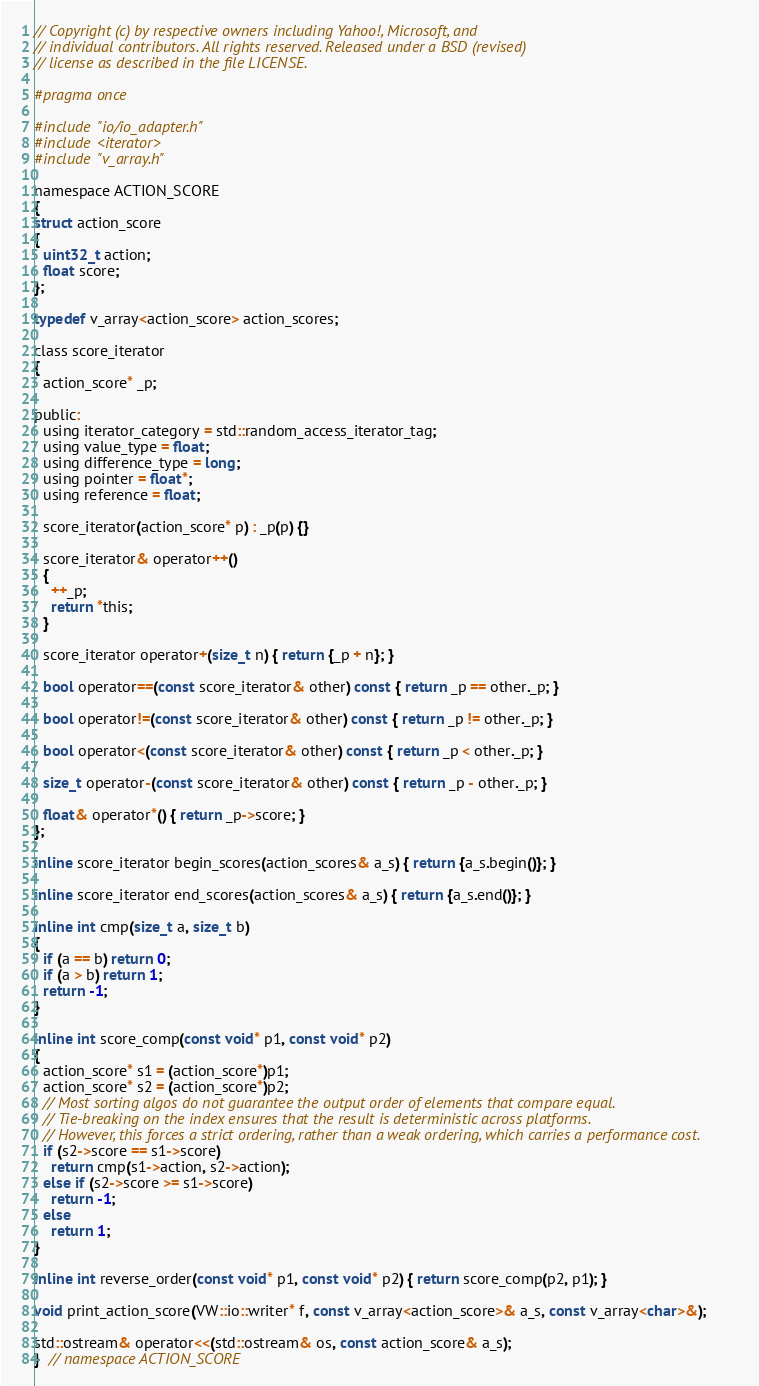<code> <loc_0><loc_0><loc_500><loc_500><_C_>// Copyright (c) by respective owners including Yahoo!, Microsoft, and
// individual contributors. All rights reserved. Released under a BSD (revised)
// license as described in the file LICENSE.

#pragma once

#include "io/io_adapter.h"
#include <iterator>
#include "v_array.h"

namespace ACTION_SCORE
{
struct action_score
{
  uint32_t action;
  float score;
};

typedef v_array<action_score> action_scores;

class score_iterator
{
  action_score* _p;

public:
  using iterator_category = std::random_access_iterator_tag;
  using value_type = float;
  using difference_type = long;
  using pointer = float*;
  using reference = float;

  score_iterator(action_score* p) : _p(p) {}

  score_iterator& operator++()
  {
    ++_p;
    return *this;
  }

  score_iterator operator+(size_t n) { return {_p + n}; }

  bool operator==(const score_iterator& other) const { return _p == other._p; }

  bool operator!=(const score_iterator& other) const { return _p != other._p; }

  bool operator<(const score_iterator& other) const { return _p < other._p; }

  size_t operator-(const score_iterator& other) const { return _p - other._p; }

  float& operator*() { return _p->score; }
};

inline score_iterator begin_scores(action_scores& a_s) { return {a_s.begin()}; }

inline score_iterator end_scores(action_scores& a_s) { return {a_s.end()}; }

inline int cmp(size_t a, size_t b)
{
  if (a == b) return 0;
  if (a > b) return 1;
  return -1;
}

inline int score_comp(const void* p1, const void* p2)
{
  action_score* s1 = (action_score*)p1;
  action_score* s2 = (action_score*)p2;
  // Most sorting algos do not guarantee the output order of elements that compare equal.
  // Tie-breaking on the index ensures that the result is deterministic across platforms.
  // However, this forces a strict ordering, rather than a weak ordering, which carries a performance cost.
  if (s2->score == s1->score)
    return cmp(s1->action, s2->action);
  else if (s2->score >= s1->score)
    return -1;
  else
    return 1;
}

inline int reverse_order(const void* p1, const void* p2) { return score_comp(p2, p1); }

void print_action_score(VW::io::writer* f, const v_array<action_score>& a_s, const v_array<char>&);

std::ostream& operator<<(std::ostream& os, const action_score& a_s);
}  // namespace ACTION_SCORE
</code> 